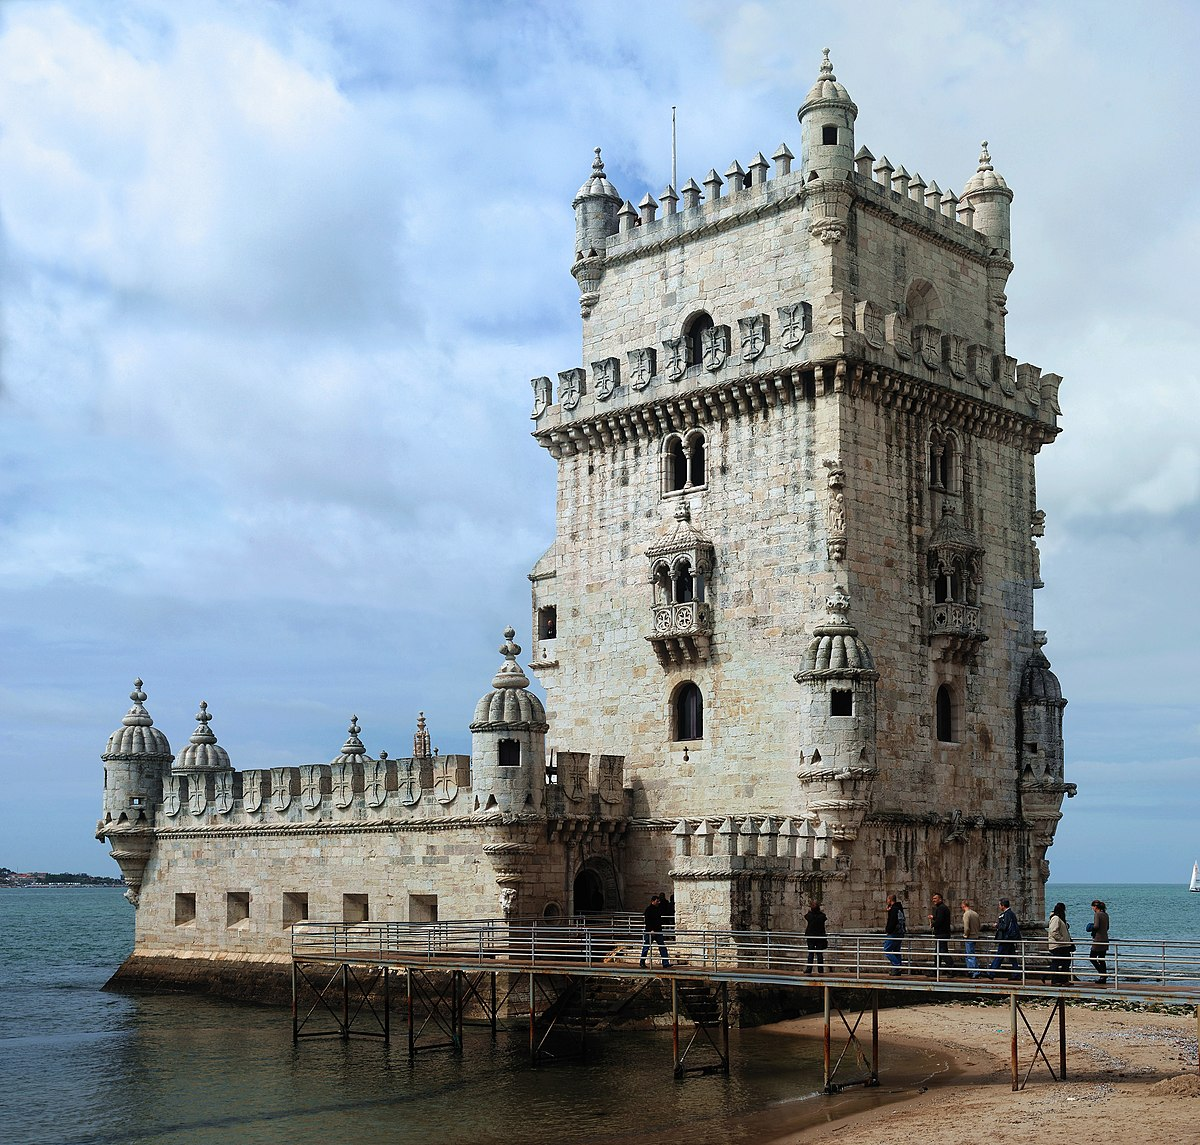Can you explain the historical significance of Belem Tower? Belem Tower was built in the early 16th century as a part of the defensive system at the mouth of the Tagus River and a ceremonial gateway to Lisbon. It is a monument to Portugal's Age of Discoveries, serving both as a fortress and a port from where many of the great Portuguese explorers embarked on their voyages. This role reflected Lisbon's importance as a maritime hub during this pivotal period in history. The tower's architecture features motifs of the Discoveries, making it a symbol of the era's expansive spirit and Portugal's progress in navigation. 